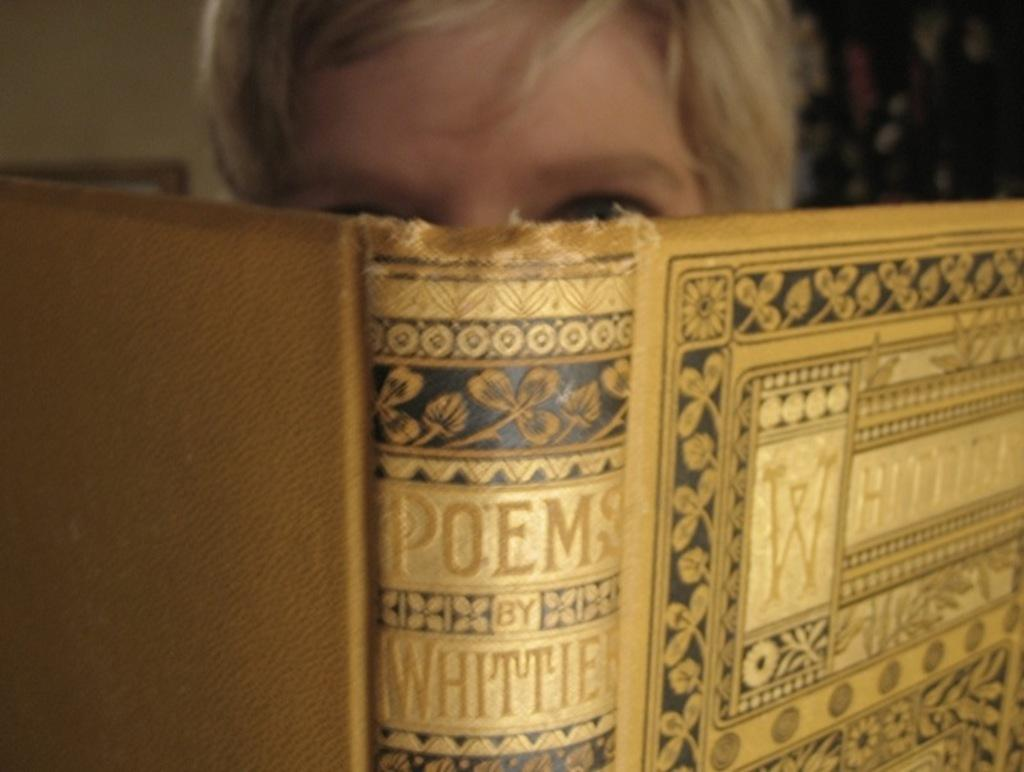Who or what is in the image? There is a person in the image. What is the person doing or interacting with in the image? There is a book in front of the person. What can be seen behind the person in the image? There is a wall in the background of the image. Are there any other objects or features visible in the background of the image? Yes, there are objects visible in the background of the image. What time of day is it in the image, and how does the person feel about their morning journey to the town? The provided facts do not mention the time of day or any journey to a town, so we cannot answer these questions based on the image. 